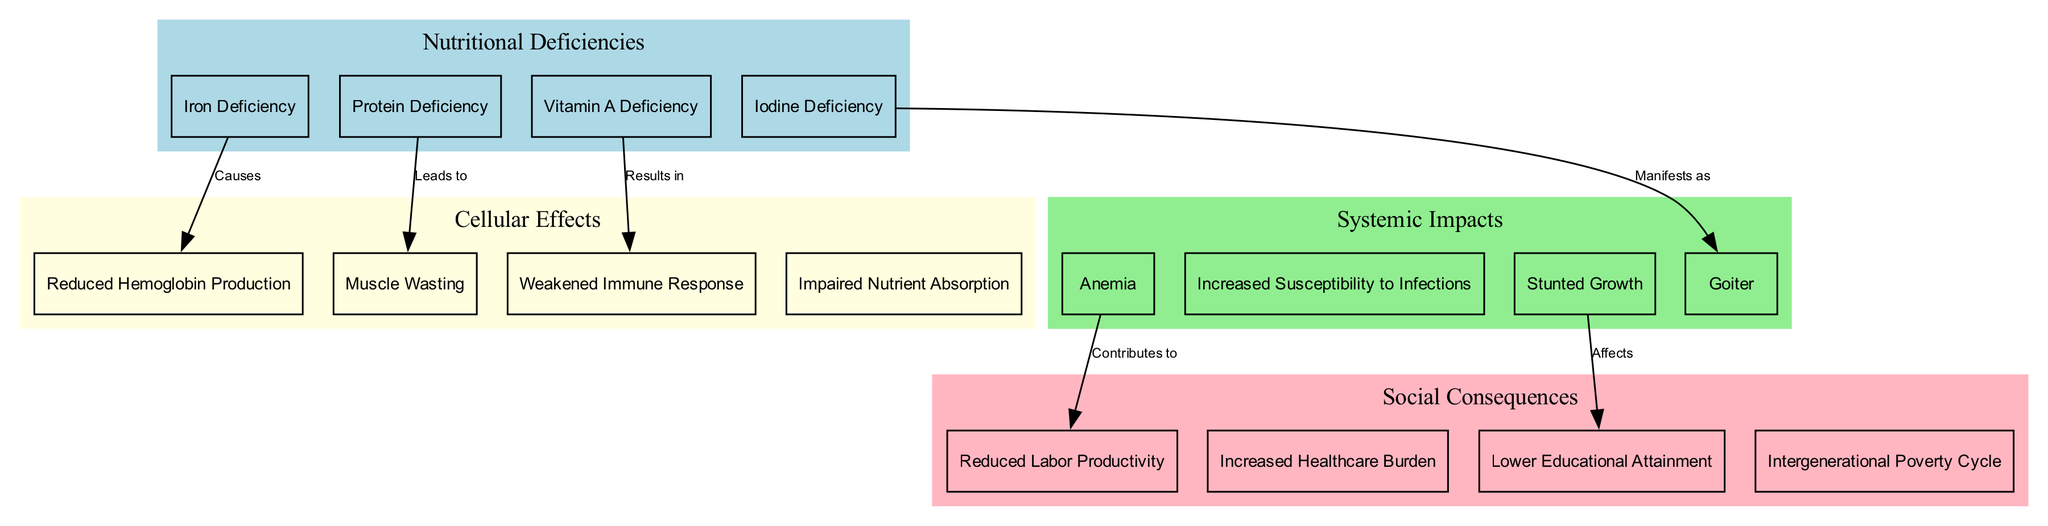What are the four cellular components depicted in the diagram? The diagram lists four cellular components: Red Blood Cell, White Blood Cell, Muscle Cell, and Intestinal Epithelial Cell under the "cellularComponents" section.
Answer: Red Blood Cell, White Blood Cell, Muscle Cell, Intestinal Epithelial Cell Which nutritional deficiency causes reduced hemoglobin production? The diagram connects Iron Deficiency with Reduced Hemoglobin Production, indicating that it is the cause.
Answer: Iron Deficiency How many total systemic impacts are mentioned in the diagram? By counting the items listed under the "systemicImpacts", there are four listed: Anemia, Increased Susceptibility to Infections, Stunted Growth, and Goiter.
Answer: 4 What are the consequences of anemia as indicated in the diagram? The diagram indicates that Anemia contributes to Reduced Labor Productivity, which is shown as a connection from Anemia to Reduced Labor Productivity.
Answer: Reduced Labor Productivity What is the relation between stunted growth and educational attainment? The diagram shows that Stunted Growth affects Lower Educational Attainment, indicating a negative impact on education due to stunting.
Answer: Affects Which nutritional deficiency results in a weakened immune response? Vitamin A Deficiency is linked to the consequence of a weakened immune response, as shown in the connections.
Answer: Vitamin A Deficiency How many edges connect nutritional deficiencies to cellular effects? Upon examining the connections in the diagram, there are four edges connecting nutritional deficiencies to their corresponding cellular effects: Iron Deficiency to Reduced Hemoglobin Production, Protein Deficiency to Muscle Wasting, Vitamin A Deficiency to Weakened Immune Response, and Iodine Deficiency to Goiter.
Answer: 4 What systemic impact manifests as a result of iodine deficiency? The diagram directly connects Iodine Deficiency with Goiter, showing that it manifests as this specific systemic impact.
Answer: Goiter What effect does vitamin A deficiency have on the immune system? The diagram indicates that Vitamin A Deficiency results in a weakened immune response, correlating the deficiency with its effect on immunity.
Answer: Weakened Immune Response 